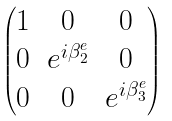Convert formula to latex. <formula><loc_0><loc_0><loc_500><loc_500>\begin{pmatrix} 1 & 0 & 0 \\ 0 & e ^ { i \beta ^ { e } _ { 2 } } & 0 \\ 0 & 0 & e ^ { i \beta ^ { e } _ { 3 } } \end{pmatrix}</formula> 